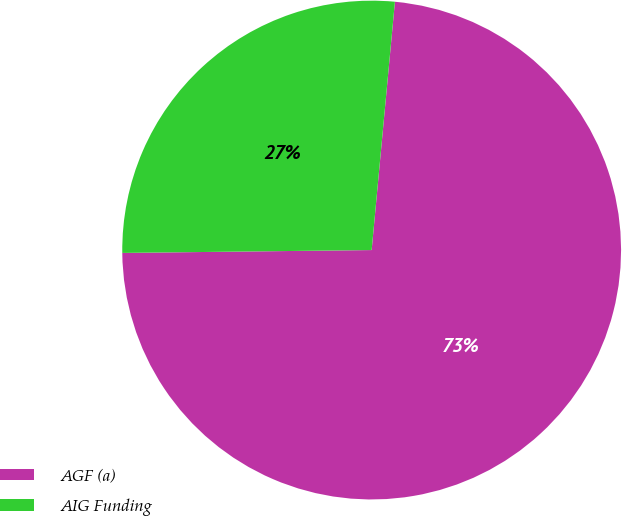Convert chart to OTSL. <chart><loc_0><loc_0><loc_500><loc_500><pie_chart><fcel>AGF (a)<fcel>AIG Funding<nl><fcel>73.33%<fcel>26.67%<nl></chart> 